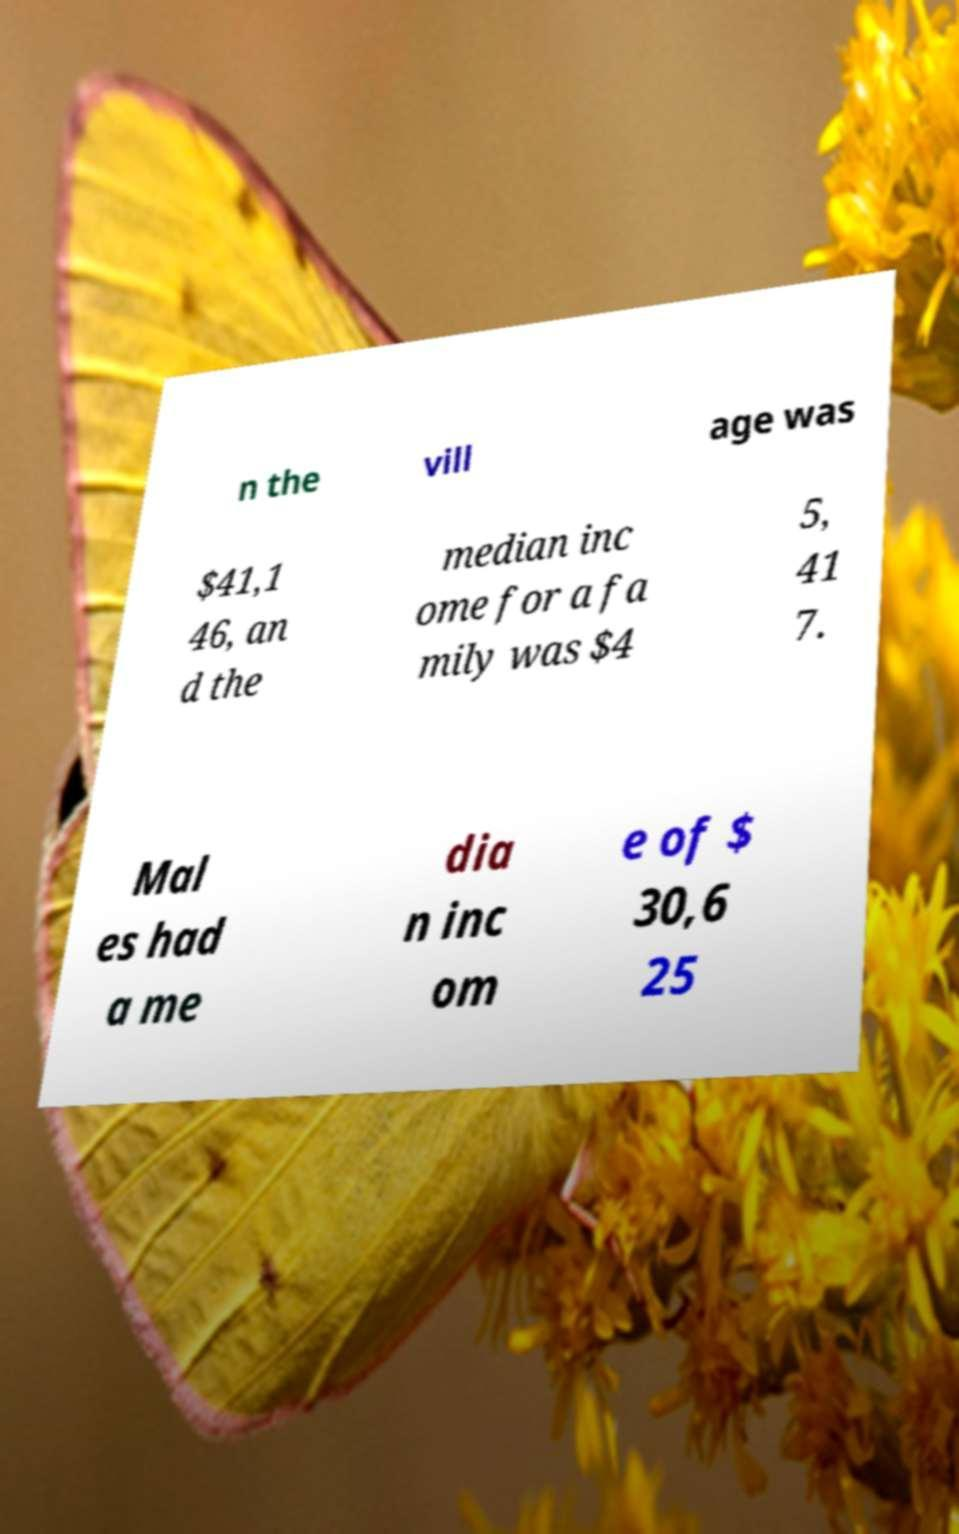Could you extract and type out the text from this image? n the vill age was $41,1 46, an d the median inc ome for a fa mily was $4 5, 41 7. Mal es had a me dia n inc om e of $ 30,6 25 